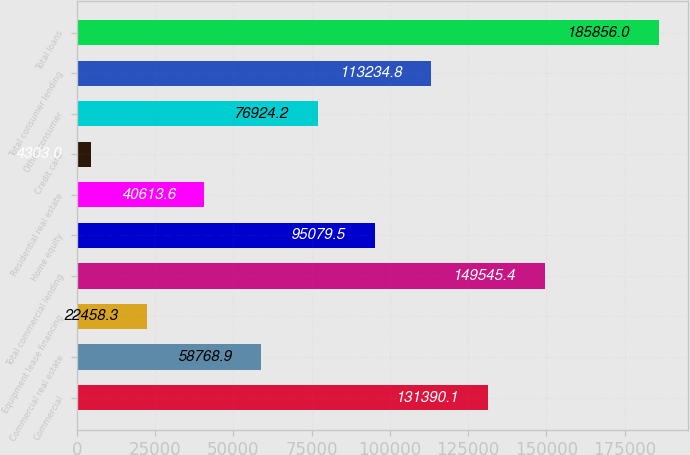Convert chart to OTSL. <chart><loc_0><loc_0><loc_500><loc_500><bar_chart><fcel>Commercial<fcel>Commercial real estate<fcel>Equipment lease financing<fcel>Total commercial lending<fcel>Home equity<fcel>Residential real estate<fcel>Credit card<fcel>Other consumer<fcel>Total consumer lending<fcel>Total loans<nl><fcel>131390<fcel>58768.9<fcel>22458.3<fcel>149545<fcel>95079.5<fcel>40613.6<fcel>4303<fcel>76924.2<fcel>113235<fcel>185856<nl></chart> 